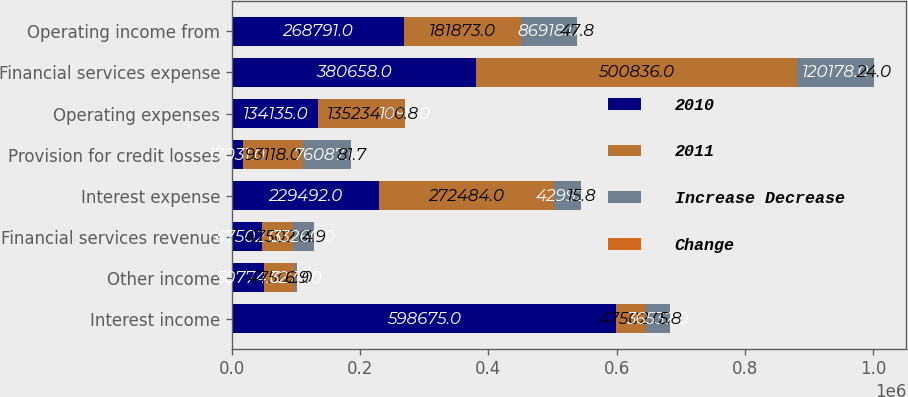Convert chart to OTSL. <chart><loc_0><loc_0><loc_500><loc_500><stacked_bar_chart><ecel><fcel>Interest income<fcel>Other income<fcel>Financial services revenue<fcel>Interest expense<fcel>Provision for credit losses<fcel>Operating expenses<fcel>Financial services expense<fcel>Operating income from<nl><fcel>2010<fcel>598675<fcel>50774<fcel>47502<fcel>229492<fcel>17031<fcel>134135<fcel>380658<fcel>268791<nl><fcel>2011<fcel>47502<fcel>47502<fcel>47502<fcel>272484<fcel>93118<fcel>135234<fcel>500836<fcel>181873<nl><fcel>Increase Decrease<fcel>36532<fcel>3272<fcel>33260<fcel>42992<fcel>76087<fcel>1099<fcel>120178<fcel>86918<nl><fcel>Change<fcel>5.8<fcel>6.9<fcel>4.9<fcel>15.8<fcel>81.7<fcel>0.8<fcel>24<fcel>47.8<nl></chart> 